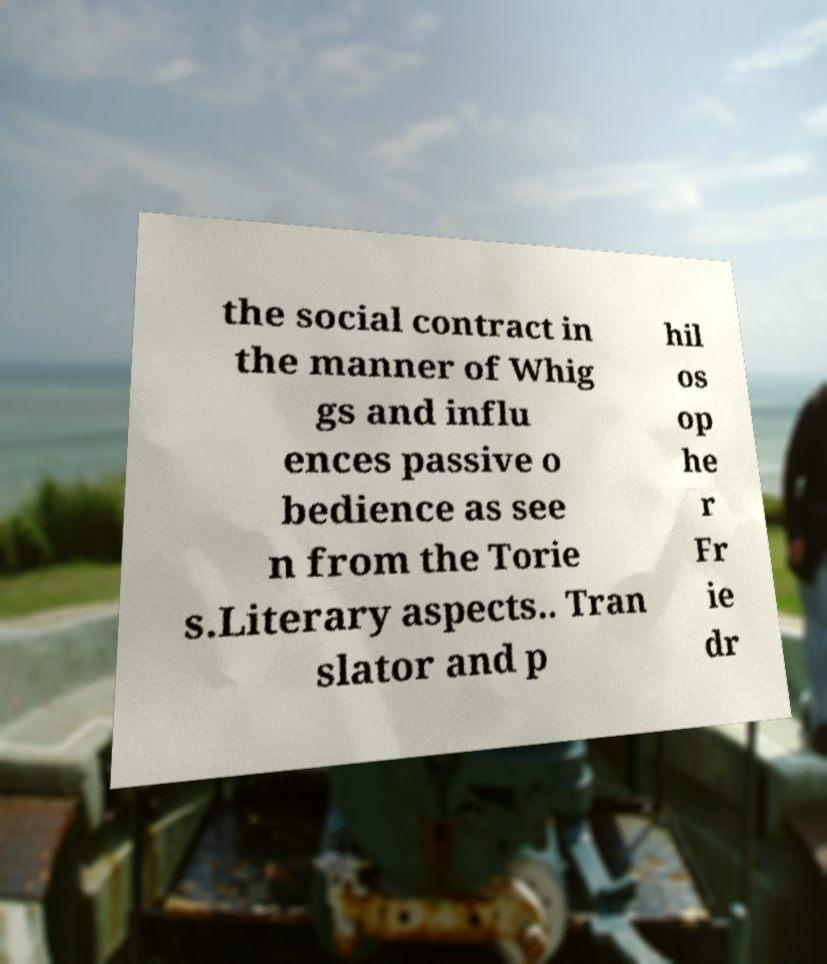Could you assist in decoding the text presented in this image and type it out clearly? the social contract in the manner of Whig gs and influ ences passive o bedience as see n from the Torie s.Literary aspects.. Tran slator and p hil os op he r Fr ie dr 